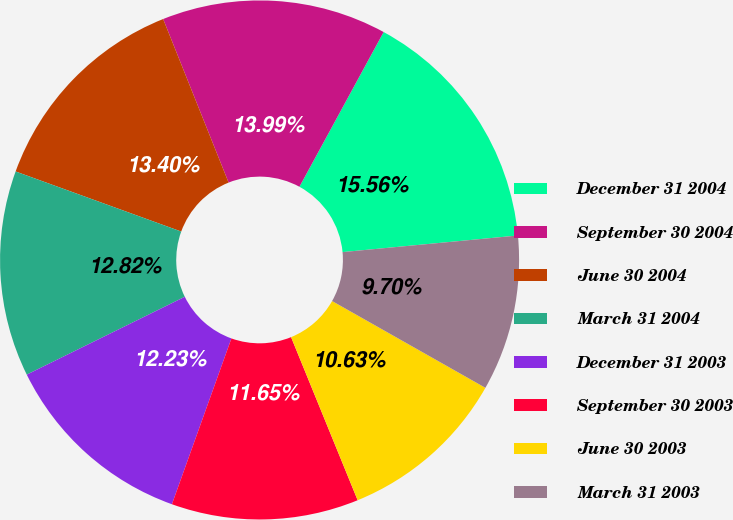Convert chart. <chart><loc_0><loc_0><loc_500><loc_500><pie_chart><fcel>December 31 2004<fcel>September 30 2004<fcel>June 30 2004<fcel>March 31 2004<fcel>December 31 2003<fcel>September 30 2003<fcel>June 30 2003<fcel>March 31 2003<nl><fcel>15.56%<fcel>13.99%<fcel>13.4%<fcel>12.82%<fcel>12.23%<fcel>11.65%<fcel>10.63%<fcel>9.7%<nl></chart> 